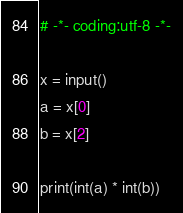Convert code to text. <code><loc_0><loc_0><loc_500><loc_500><_Python_># -*- coding:utf-8 -*-

x = input()
a = x[0]
b = x[2]

print(int(a) * int(b))</code> 